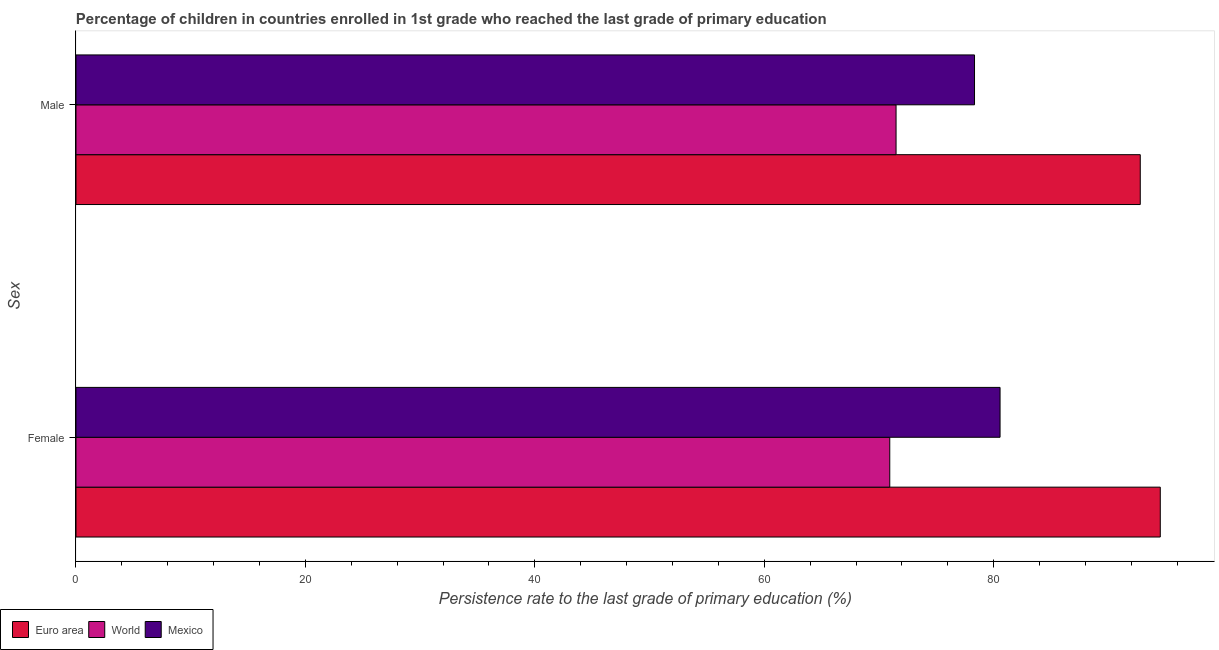Are the number of bars per tick equal to the number of legend labels?
Offer a terse response. Yes. How many bars are there on the 1st tick from the top?
Keep it short and to the point. 3. What is the label of the 1st group of bars from the top?
Your answer should be very brief. Male. What is the persistence rate of female students in Euro area?
Your answer should be very brief. 94.52. Across all countries, what is the maximum persistence rate of male students?
Provide a succinct answer. 92.78. Across all countries, what is the minimum persistence rate of male students?
Offer a very short reply. 71.49. In which country was the persistence rate of female students maximum?
Provide a short and direct response. Euro area. In which country was the persistence rate of male students minimum?
Your answer should be compact. World. What is the total persistence rate of female students in the graph?
Ensure brevity in your answer.  246.01. What is the difference between the persistence rate of female students in World and that in Euro area?
Your answer should be very brief. -23.58. What is the difference between the persistence rate of male students in Mexico and the persistence rate of female students in Euro area?
Your answer should be compact. -16.19. What is the average persistence rate of male students per country?
Offer a terse response. 80.86. What is the difference between the persistence rate of male students and persistence rate of female students in Euro area?
Keep it short and to the point. -1.74. What is the ratio of the persistence rate of female students in Euro area to that in Mexico?
Make the answer very short. 1.17. In how many countries, is the persistence rate of female students greater than the average persistence rate of female students taken over all countries?
Your answer should be compact. 1. What does the 1st bar from the bottom in Female represents?
Provide a succinct answer. Euro area. Are all the bars in the graph horizontal?
Your answer should be very brief. Yes. How many countries are there in the graph?
Your answer should be compact. 3. Are the values on the major ticks of X-axis written in scientific E-notation?
Keep it short and to the point. No. Does the graph contain any zero values?
Provide a short and direct response. No. Does the graph contain grids?
Offer a terse response. No. How many legend labels are there?
Provide a succinct answer. 3. How are the legend labels stacked?
Keep it short and to the point. Horizontal. What is the title of the graph?
Offer a very short reply. Percentage of children in countries enrolled in 1st grade who reached the last grade of primary education. What is the label or title of the X-axis?
Offer a terse response. Persistence rate to the last grade of primary education (%). What is the label or title of the Y-axis?
Your answer should be compact. Sex. What is the Persistence rate to the last grade of primary education (%) of Euro area in Female?
Give a very brief answer. 94.52. What is the Persistence rate to the last grade of primary education (%) in World in Female?
Keep it short and to the point. 70.94. What is the Persistence rate to the last grade of primary education (%) of Mexico in Female?
Provide a short and direct response. 80.55. What is the Persistence rate to the last grade of primary education (%) in Euro area in Male?
Offer a terse response. 92.78. What is the Persistence rate to the last grade of primary education (%) of World in Male?
Ensure brevity in your answer.  71.49. What is the Persistence rate to the last grade of primary education (%) of Mexico in Male?
Provide a succinct answer. 78.33. Across all Sex, what is the maximum Persistence rate to the last grade of primary education (%) of Euro area?
Keep it short and to the point. 94.52. Across all Sex, what is the maximum Persistence rate to the last grade of primary education (%) in World?
Make the answer very short. 71.49. Across all Sex, what is the maximum Persistence rate to the last grade of primary education (%) of Mexico?
Provide a short and direct response. 80.55. Across all Sex, what is the minimum Persistence rate to the last grade of primary education (%) of Euro area?
Your answer should be very brief. 92.78. Across all Sex, what is the minimum Persistence rate to the last grade of primary education (%) of World?
Your response must be concise. 70.94. Across all Sex, what is the minimum Persistence rate to the last grade of primary education (%) in Mexico?
Ensure brevity in your answer.  78.33. What is the total Persistence rate to the last grade of primary education (%) in Euro area in the graph?
Your answer should be very brief. 187.3. What is the total Persistence rate to the last grade of primary education (%) of World in the graph?
Ensure brevity in your answer.  142.43. What is the total Persistence rate to the last grade of primary education (%) of Mexico in the graph?
Offer a very short reply. 158.88. What is the difference between the Persistence rate to the last grade of primary education (%) in Euro area in Female and that in Male?
Give a very brief answer. 1.74. What is the difference between the Persistence rate to the last grade of primary education (%) in World in Female and that in Male?
Your answer should be compact. -0.55. What is the difference between the Persistence rate to the last grade of primary education (%) in Mexico in Female and that in Male?
Your answer should be compact. 2.23. What is the difference between the Persistence rate to the last grade of primary education (%) of Euro area in Female and the Persistence rate to the last grade of primary education (%) of World in Male?
Provide a succinct answer. 23.03. What is the difference between the Persistence rate to the last grade of primary education (%) of Euro area in Female and the Persistence rate to the last grade of primary education (%) of Mexico in Male?
Offer a very short reply. 16.19. What is the difference between the Persistence rate to the last grade of primary education (%) of World in Female and the Persistence rate to the last grade of primary education (%) of Mexico in Male?
Make the answer very short. -7.39. What is the average Persistence rate to the last grade of primary education (%) of Euro area per Sex?
Keep it short and to the point. 93.65. What is the average Persistence rate to the last grade of primary education (%) in World per Sex?
Offer a terse response. 71.21. What is the average Persistence rate to the last grade of primary education (%) of Mexico per Sex?
Give a very brief answer. 79.44. What is the difference between the Persistence rate to the last grade of primary education (%) in Euro area and Persistence rate to the last grade of primary education (%) in World in Female?
Keep it short and to the point. 23.58. What is the difference between the Persistence rate to the last grade of primary education (%) of Euro area and Persistence rate to the last grade of primary education (%) of Mexico in Female?
Your answer should be compact. 13.97. What is the difference between the Persistence rate to the last grade of primary education (%) in World and Persistence rate to the last grade of primary education (%) in Mexico in Female?
Offer a very short reply. -9.61. What is the difference between the Persistence rate to the last grade of primary education (%) of Euro area and Persistence rate to the last grade of primary education (%) of World in Male?
Provide a succinct answer. 21.29. What is the difference between the Persistence rate to the last grade of primary education (%) of Euro area and Persistence rate to the last grade of primary education (%) of Mexico in Male?
Offer a terse response. 14.45. What is the difference between the Persistence rate to the last grade of primary education (%) in World and Persistence rate to the last grade of primary education (%) in Mexico in Male?
Your response must be concise. -6.84. What is the ratio of the Persistence rate to the last grade of primary education (%) in Euro area in Female to that in Male?
Provide a short and direct response. 1.02. What is the ratio of the Persistence rate to the last grade of primary education (%) in World in Female to that in Male?
Keep it short and to the point. 0.99. What is the ratio of the Persistence rate to the last grade of primary education (%) in Mexico in Female to that in Male?
Provide a short and direct response. 1.03. What is the difference between the highest and the second highest Persistence rate to the last grade of primary education (%) of Euro area?
Your response must be concise. 1.74. What is the difference between the highest and the second highest Persistence rate to the last grade of primary education (%) of World?
Provide a short and direct response. 0.55. What is the difference between the highest and the second highest Persistence rate to the last grade of primary education (%) of Mexico?
Provide a succinct answer. 2.23. What is the difference between the highest and the lowest Persistence rate to the last grade of primary education (%) of Euro area?
Give a very brief answer. 1.74. What is the difference between the highest and the lowest Persistence rate to the last grade of primary education (%) in World?
Provide a succinct answer. 0.55. What is the difference between the highest and the lowest Persistence rate to the last grade of primary education (%) in Mexico?
Provide a short and direct response. 2.23. 